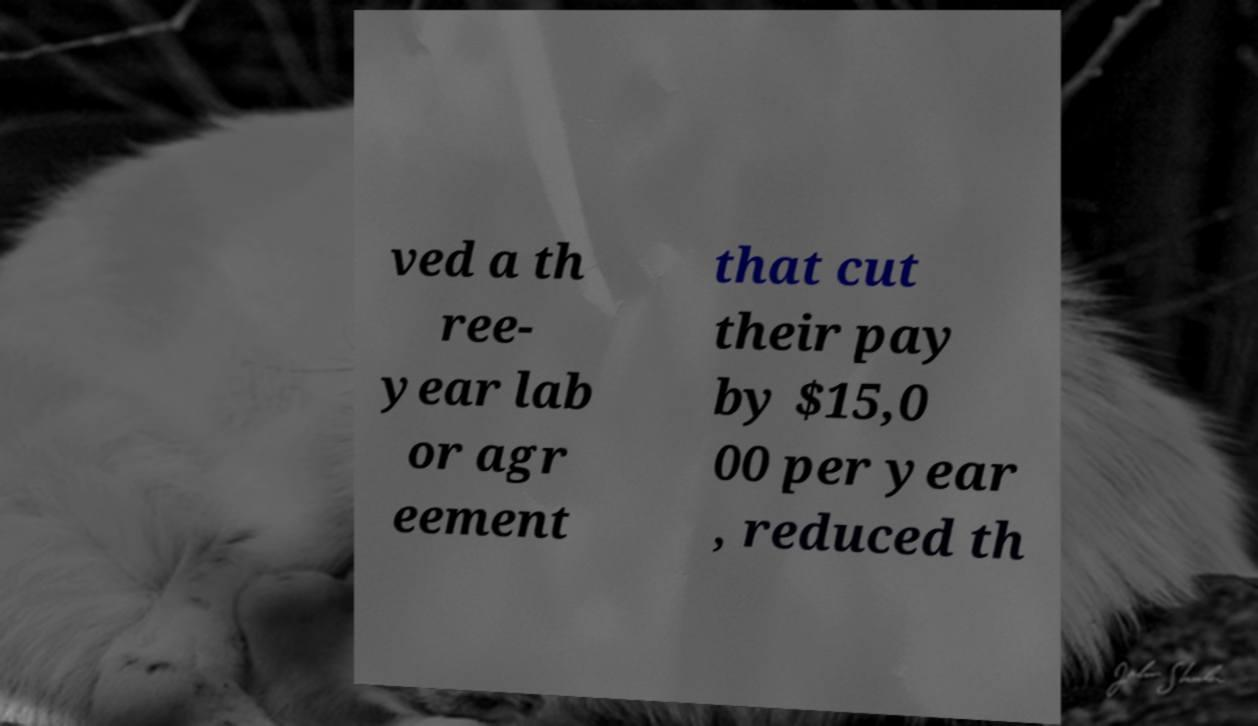For documentation purposes, I need the text within this image transcribed. Could you provide that? ved a th ree- year lab or agr eement that cut their pay by $15,0 00 per year , reduced th 